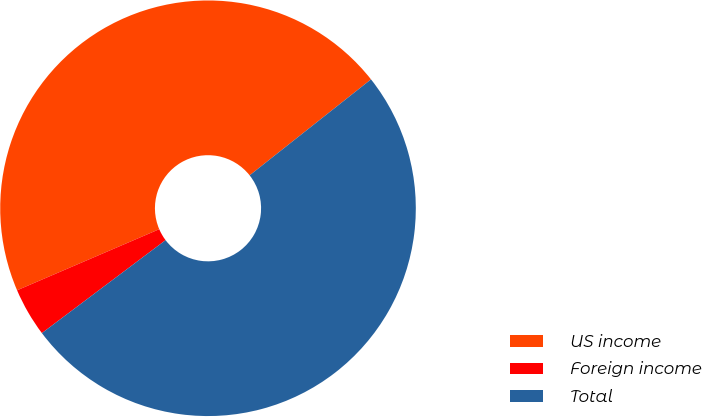<chart> <loc_0><loc_0><loc_500><loc_500><pie_chart><fcel>US income<fcel>Foreign income<fcel>Total<nl><fcel>45.81%<fcel>3.8%<fcel>50.39%<nl></chart> 